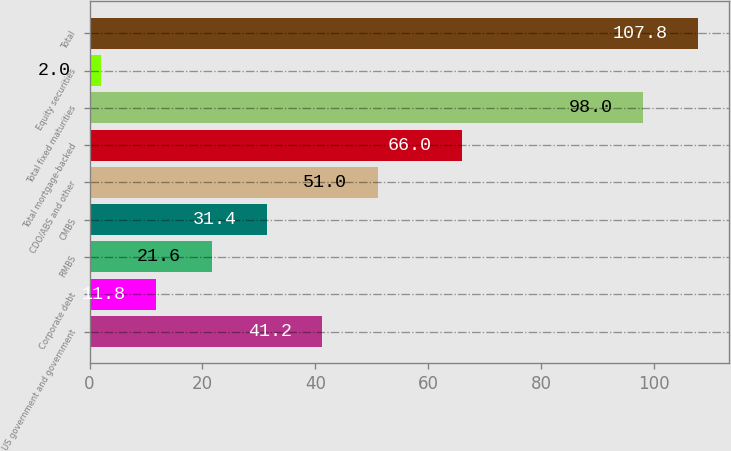Convert chart to OTSL. <chart><loc_0><loc_0><loc_500><loc_500><bar_chart><fcel>US government and government<fcel>Corporate debt<fcel>RMBS<fcel>CMBS<fcel>CDO/ABS and other<fcel>Total mortgage-backed<fcel>Total fixed maturities<fcel>Equity securities<fcel>Total<nl><fcel>41.2<fcel>11.8<fcel>21.6<fcel>31.4<fcel>51<fcel>66<fcel>98<fcel>2<fcel>107.8<nl></chart> 